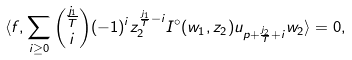<formula> <loc_0><loc_0><loc_500><loc_500>\langle f , \sum _ { i \geq 0 } \binom { \frac { j _ { 1 } } { T } } { i } ( - 1 ) ^ { i } z _ { 2 } ^ { \frac { j _ { 1 } } { T } - i } I ^ { \circ } ( w _ { 1 } , z _ { 2 } ) u _ { p + \frac { j _ { 2 } } { T } + i } w _ { 2 } \rangle = 0 ,</formula> 